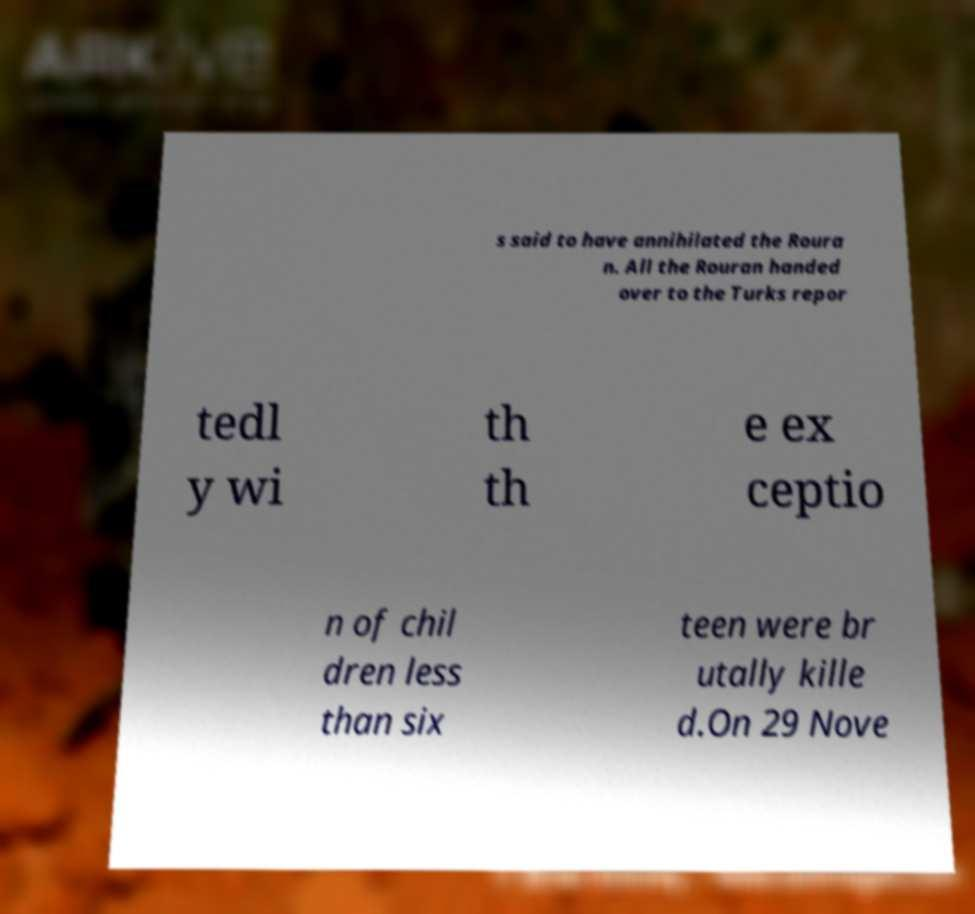Can you read and provide the text displayed in the image?This photo seems to have some interesting text. Can you extract and type it out for me? s said to have annihilated the Roura n. All the Rouran handed over to the Turks repor tedl y wi th th e ex ceptio n of chil dren less than six teen were br utally kille d.On 29 Nove 